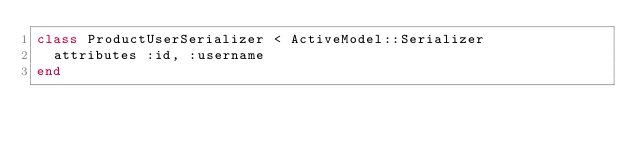<code> <loc_0><loc_0><loc_500><loc_500><_Ruby_>class ProductUserSerializer < ActiveModel::Serializer
  attributes :id, :username
end
</code> 